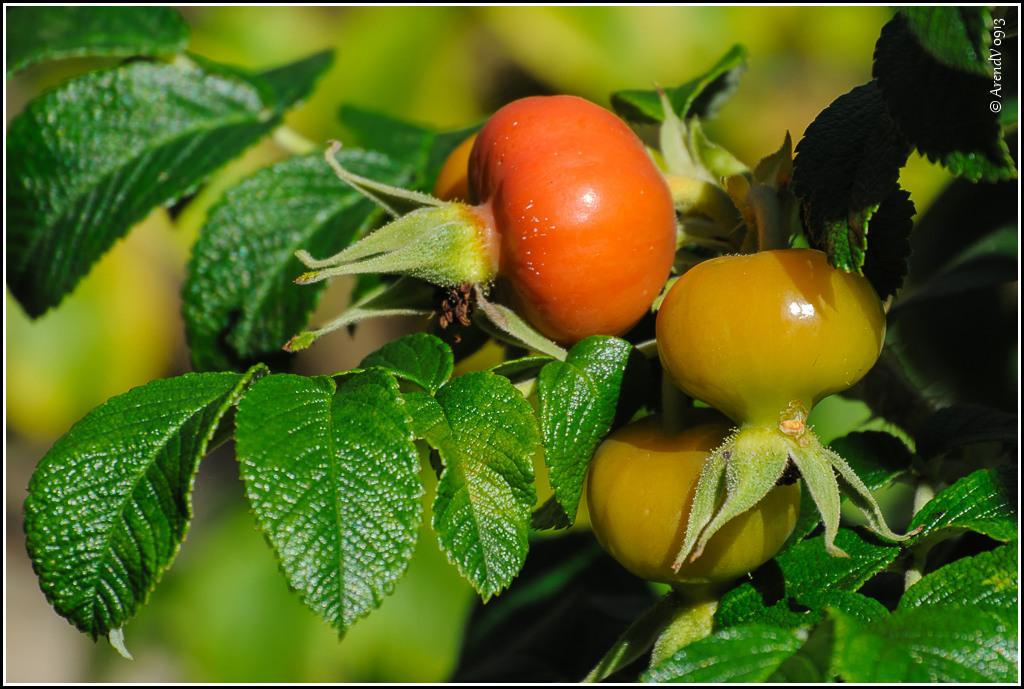What is present in the image? There is a plant in the image. What type of fruit can be seen on the plant? The plant has tomatoes. Can you describe the background of the image? The background of the image is blurry. What action are the geese performing in the image? There are no geese present in the image, so no action involving geese can be observed. 